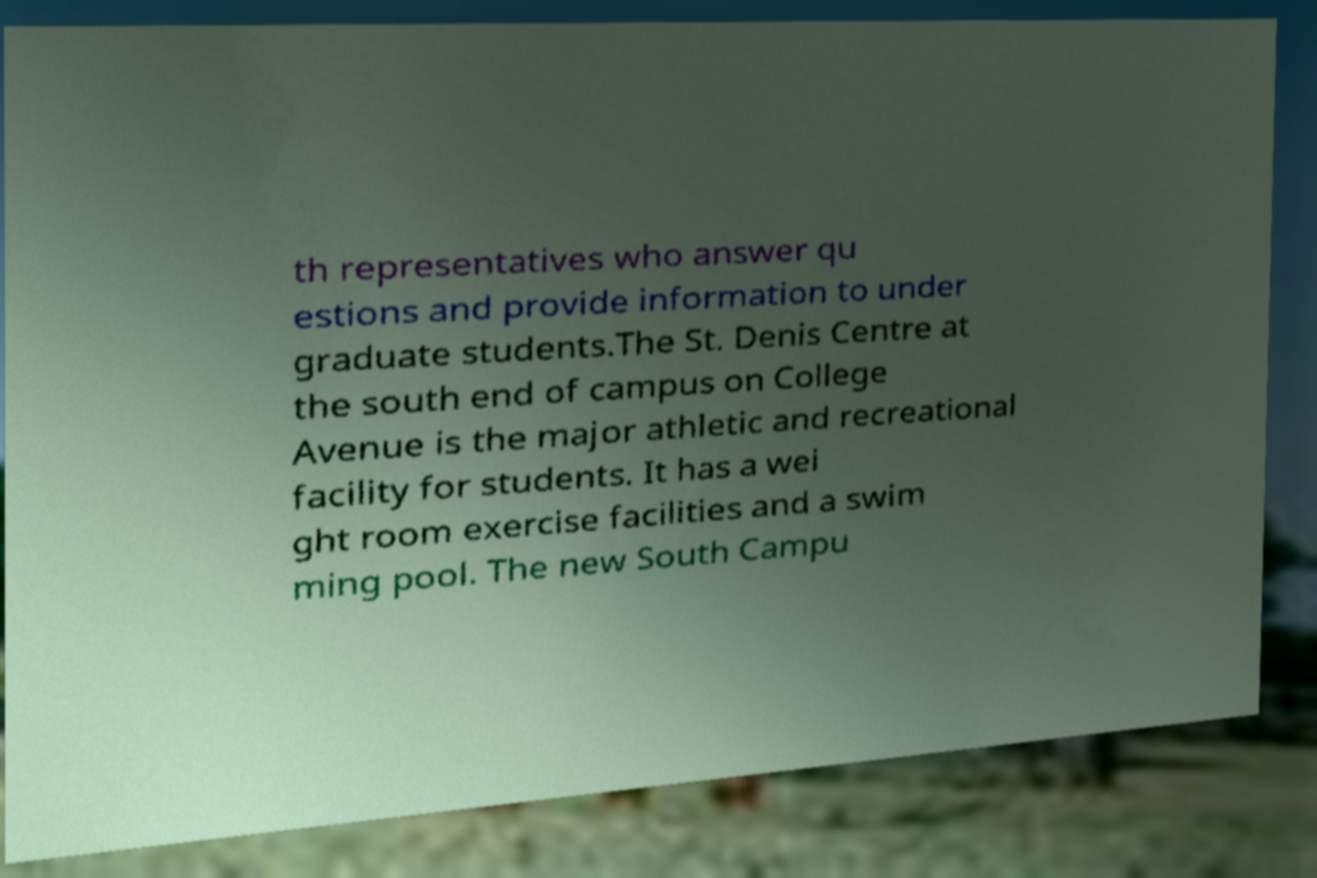Could you extract and type out the text from this image? th representatives who answer qu estions and provide information to under graduate students.The St. Denis Centre at the south end of campus on College Avenue is the major athletic and recreational facility for students. It has a wei ght room exercise facilities and a swim ming pool. The new South Campu 